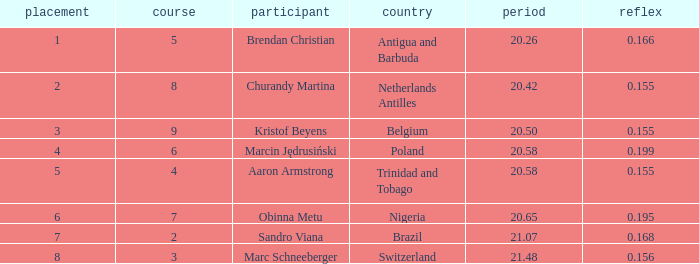How much Time has a Reaction of 0.155, and an Athlete of kristof beyens, and a Rank smaller than 3? 0.0. 